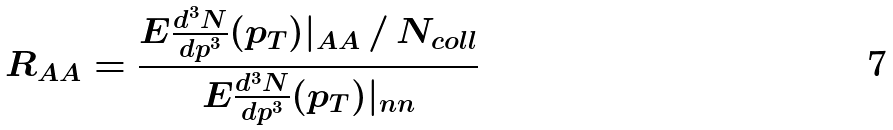<formula> <loc_0><loc_0><loc_500><loc_500>R _ { A A } = \frac { E \frac { d ^ { 3 } N } { d p ^ { 3 } } ( p _ { T } ) | _ { A A } \, / \, N _ { c o l l } } { E \frac { d ^ { 3 } N } { d p ^ { 3 } } ( p _ { T } ) | _ { n n } }</formula> 